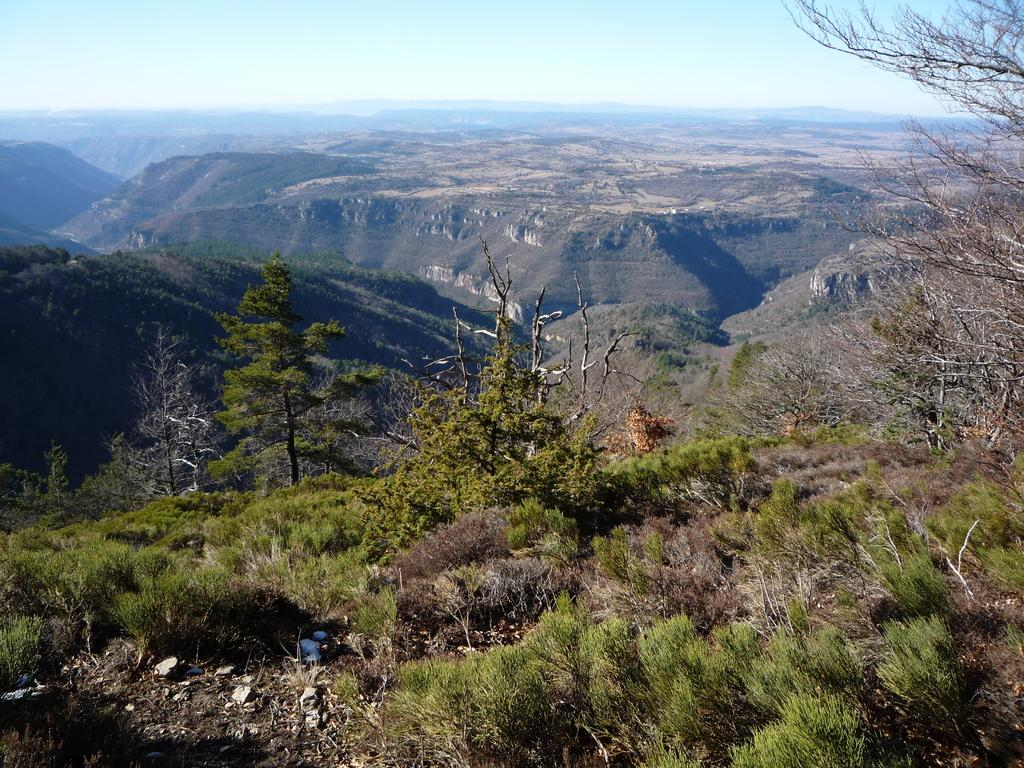What type of vegetation can be seen in the image? There are plants and trees in the image. What type of landscape feature is visible in the image? There are hills visible in the image. What is visible in the background of the image? There is a sky visible in the background of the image. What type of music can be heard coming from the trees in the image? There is no music present in the image, as it features plants, trees, and hills with a visible sky in the background. 